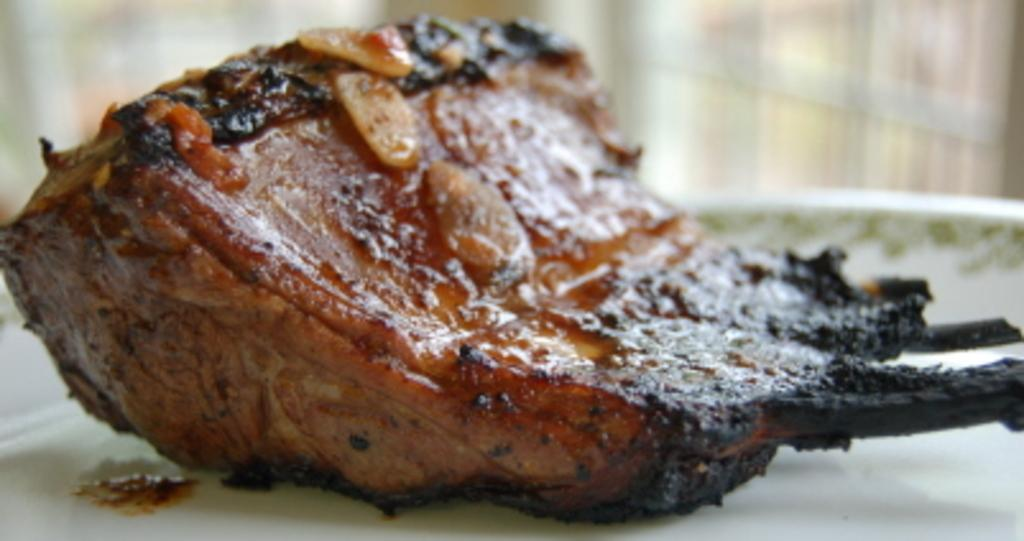What is on the plate that is visible in the image? There is food on a plate in the image. Can you describe the background of the image? The background of the image is blurry. What type of bomb is being used to create the blurry background in the image? There is no bomb present in the image, and the blurry background is not caused by a bomb. 